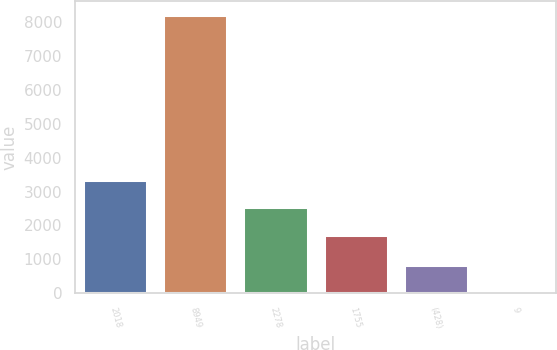Convert chart to OTSL. <chart><loc_0><loc_0><loc_500><loc_500><bar_chart><fcel>2018<fcel>8949<fcel>2278<fcel>1755<fcel>(428)<fcel>9<nl><fcel>3349.8<fcel>8218<fcel>2528.4<fcel>1707<fcel>825.4<fcel>4<nl></chart> 